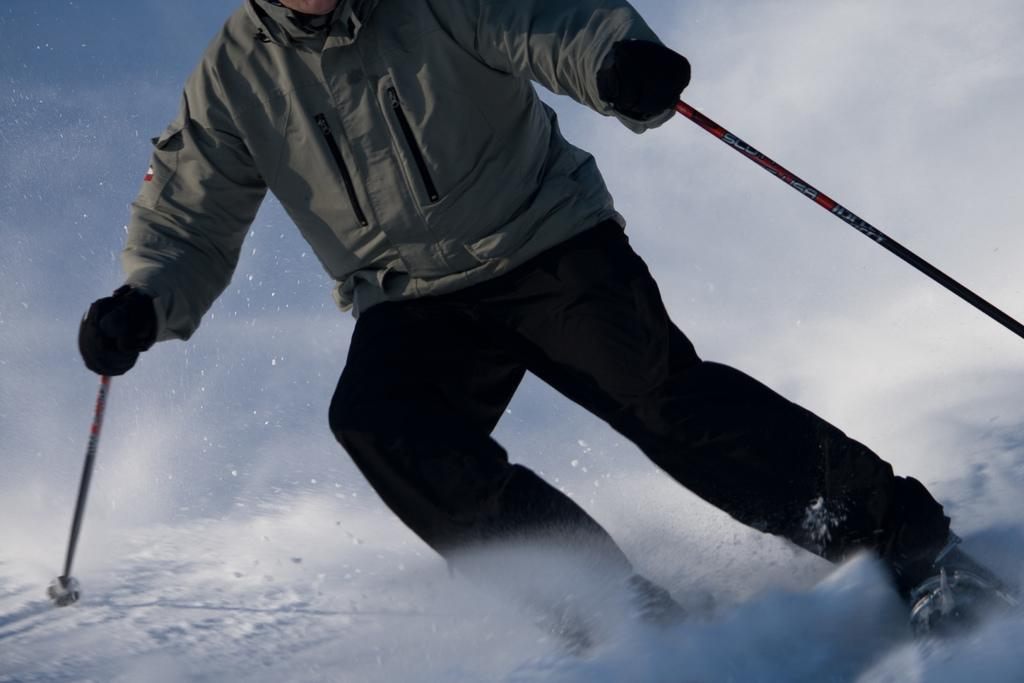What is the main subject of the image? There is a man in the image. What is the man wearing? The man is wearing a grey jacket and black pants. What activity is the man engaged in? The man is skiing. What is the surface on which the skiing is taking place? The skiing is taking place on snow. Can you see any jellyfish swimming in the snow in the image? No, there are no jellyfish present in the image, and jellyfish do not swim in snow. Is the man's digestion process visible in the image? No, the man's digestion process is not visible in the image. 